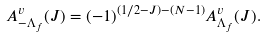<formula> <loc_0><loc_0><loc_500><loc_500>A ^ { v } _ { - \Lambda _ { f } } ( J ) = ( - 1 ) ^ { ( 1 / 2 - J ) - ( N - 1 ) } A ^ { v } _ { \Lambda _ { f } } ( J ) .</formula> 